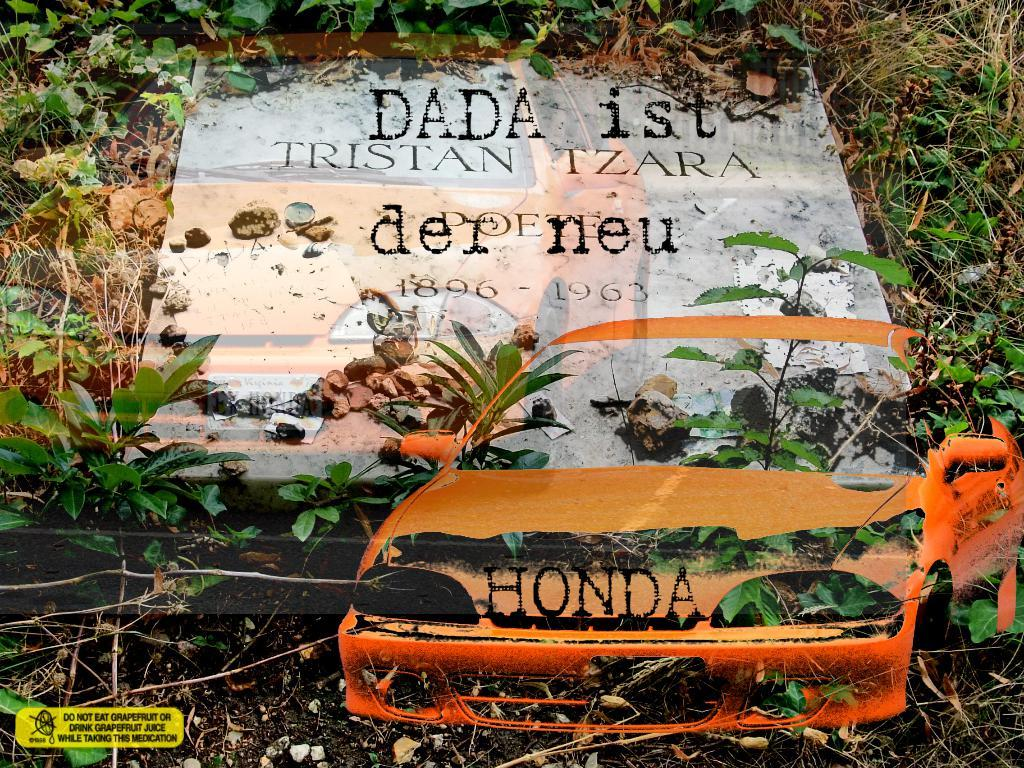What is the main subject of the picture? The main subject of the picture is a gravestone. What can be seen around the gravestone? There are plants, soil, and grass visible around the gravestone. What is the condition of the soil around the gravestone? The soil is present around the gravestone. Can you describe the watermark in the picture? The picture has a car watermark. How many snakes are slithering around the gravestone in the image? There are no snakes present in the image; it only features a gravestone, plants, soil, grass, and a car watermark. What type of tool is being used to dig around the gravestone in the image? There is no tool or digging activity depicted in the image; it only shows a gravestone, plants, soil, grass, and a car watermark. 